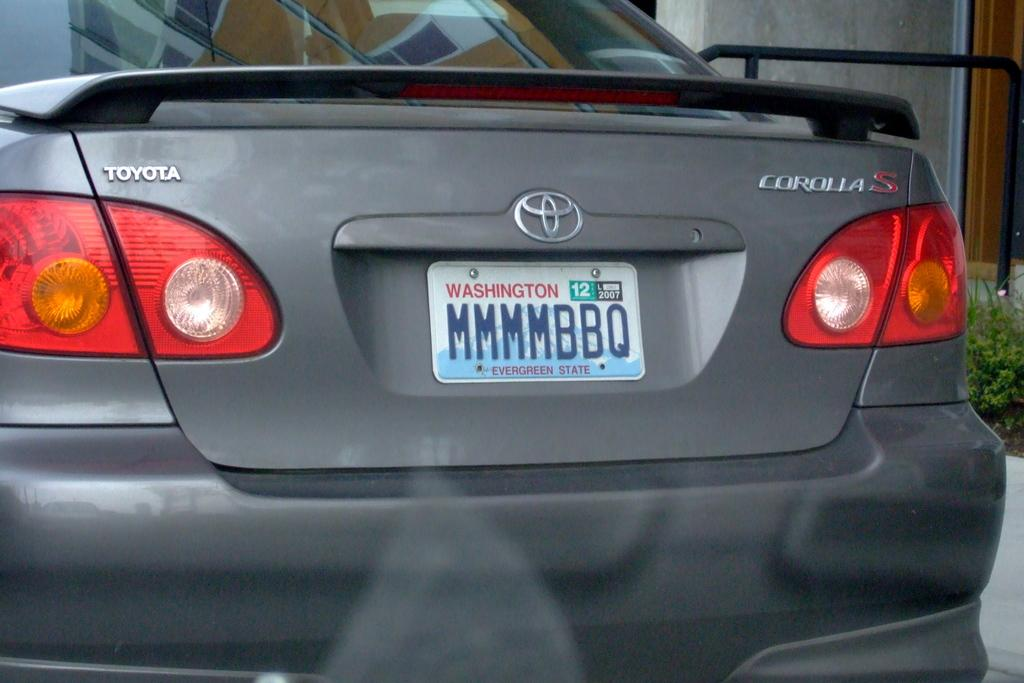What is the main subject in the front of the image? There is a car in the front of the image. What type of vegetation can be seen on the right side of the image? There is a plant on the right side of the image. What can be seen in the background of the image? There is a wall visible in the background of the image. How fast is the watch running in the image? There is no watch present in the image, so it is not possible to determine its speed. 